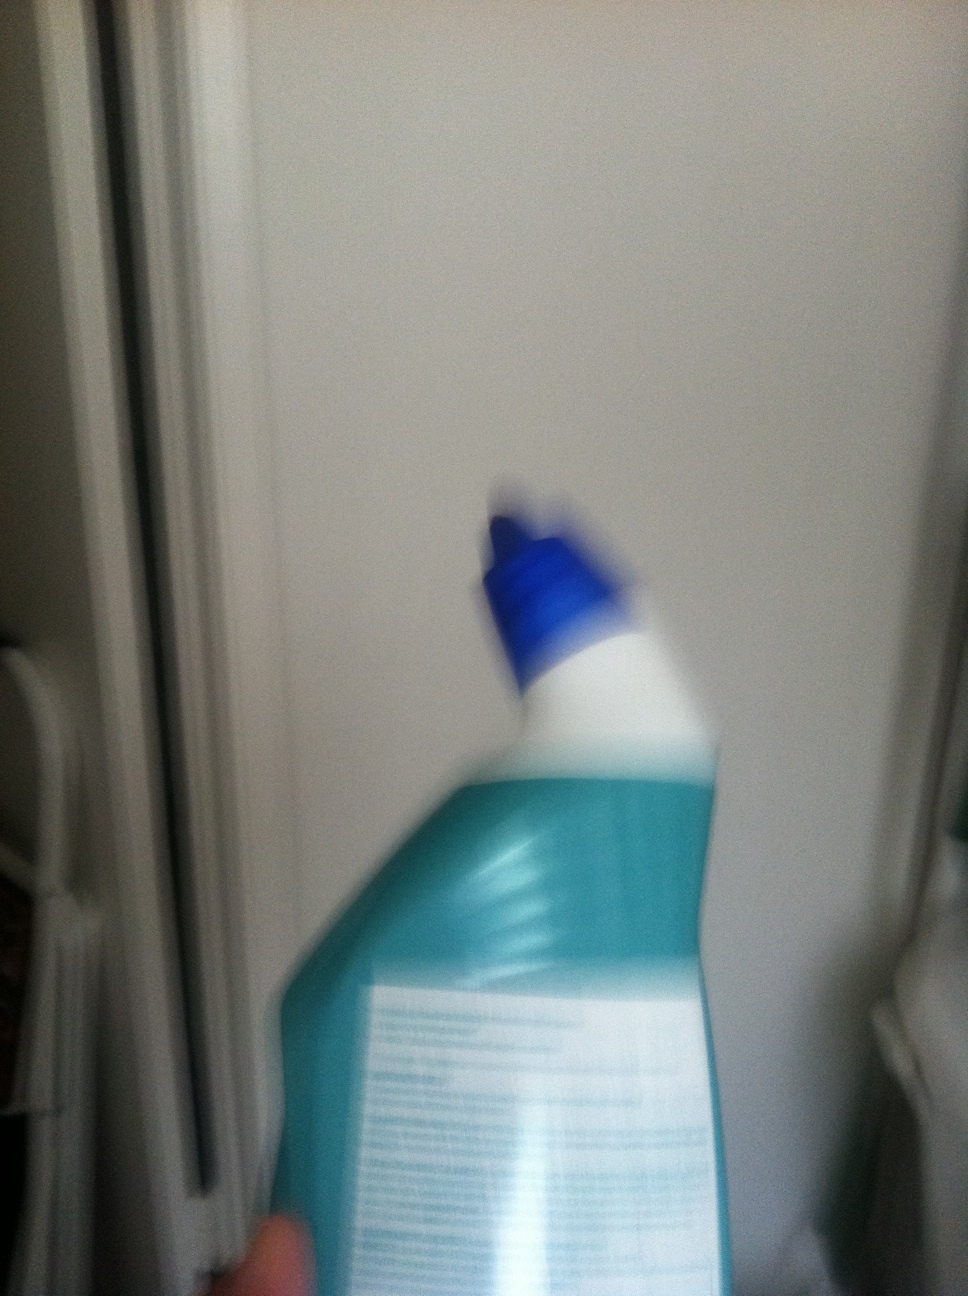Can you guess the possible use of this bottle? While the image is blurry, the bottle likely contains a household cleaning solution, given its design and cap structure which is common among such products. 